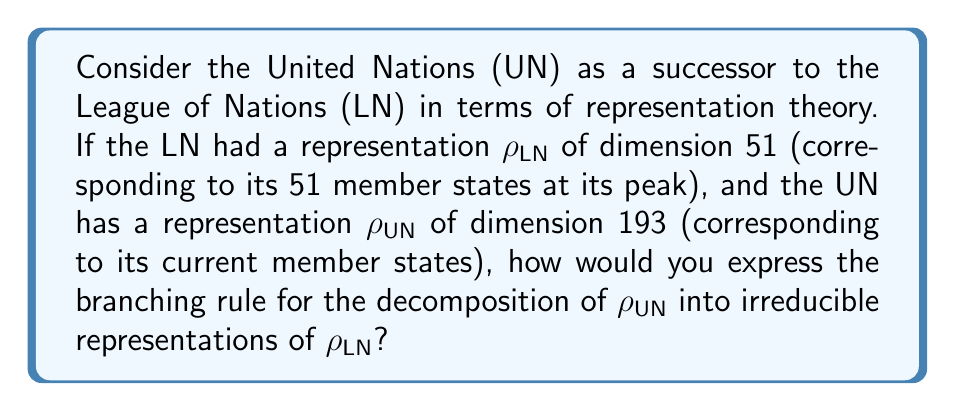Show me your answer to this math problem. To solve this problem, we need to follow these steps:

1) First, we need to understand that the branching rule describes how a representation of a larger group decomposes into representations of a subgroup. In this case, we're treating the UN as a larger group that includes the LN as a subgroup.

2) The dimension of $\rho_{LN}$ is 51, and the dimension of $\rho_{UN}$ is 193. This means that $\rho_{UN}$ must decompose into a direct sum of $\rho_{LN}$ and some other representations.

3) We can express this decomposition as:

   $$\rho_{UN} \downarrow_{LN} = \rho_{LN} \oplus \rho_{new}$$

   where $\rho_{new}$ represents the additional states in the UN that were not part of the LN.

4) The dimension of $\rho_{new}$ must be the difference between the dimensions of $\rho_{UN}$ and $\rho_{LN}$:

   $$\dim(\rho_{new}) = \dim(\rho_{UN}) - \dim(\rho_{LN}) = 193 - 51 = 142$$

5) Therefore, $\rho_{new}$ is a representation of dimension 142.

6) We can express the final branching rule as:

   $$\rho_{UN} \downarrow_{LN} = \rho_{LN} \oplus \rho_{142}$$

   where $\rho_{142}$ is an irreducible representation of dimension 142.

This branching rule shows how the representation of the UN "branches" or decomposes when restricted to the subgroup corresponding to the League of Nations.
Answer: $\rho_{UN} \downarrow_{LN} = \rho_{LN} \oplus \rho_{142}$ 